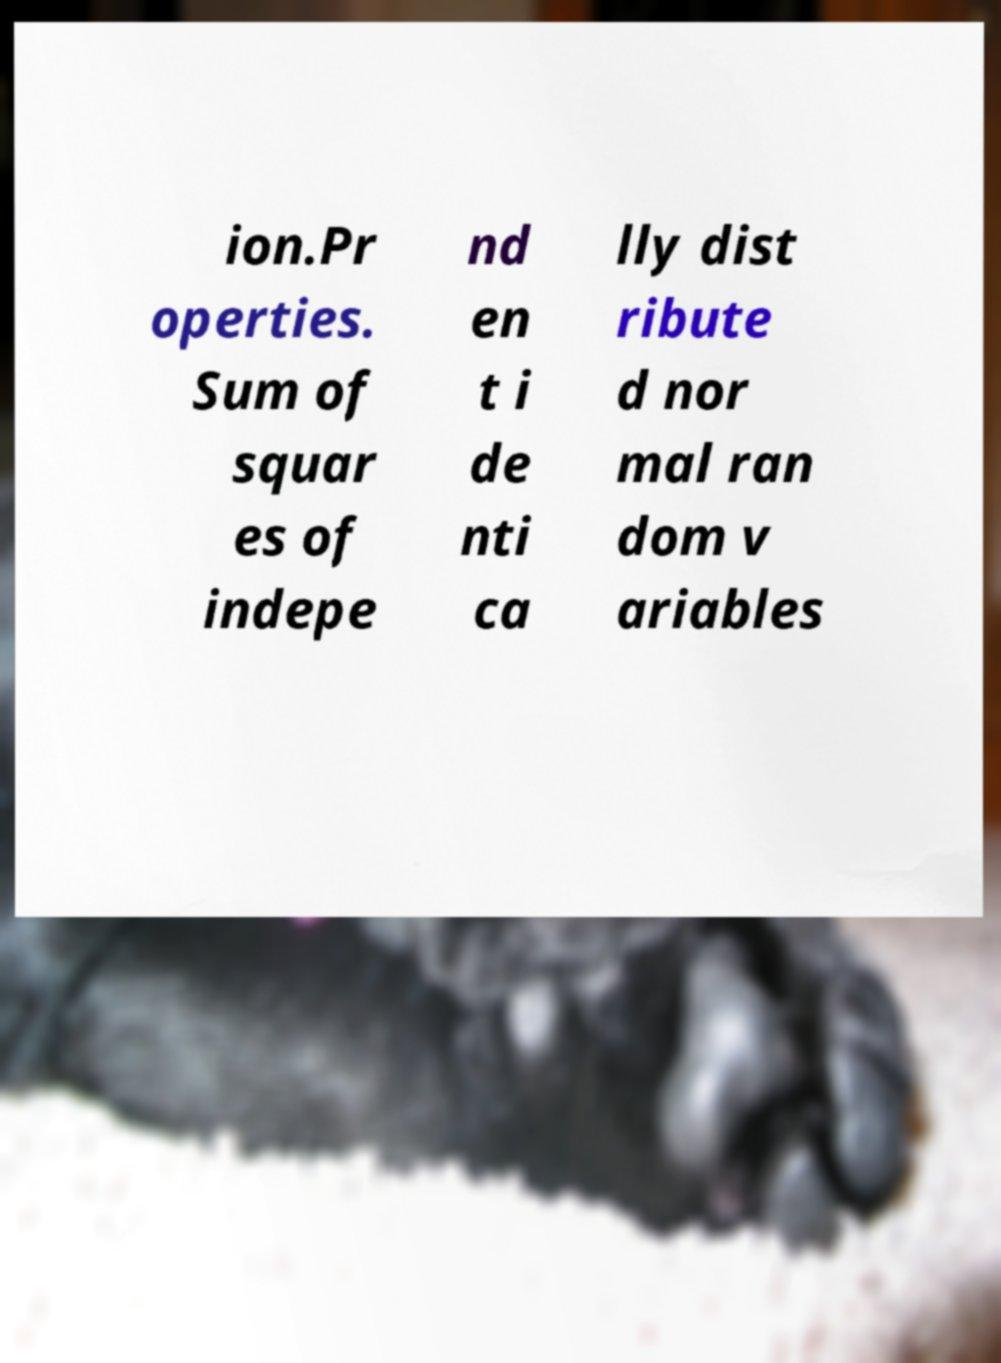Please read and relay the text visible in this image. What does it say? ion.Pr operties. Sum of squar es of indepe nd en t i de nti ca lly dist ribute d nor mal ran dom v ariables 